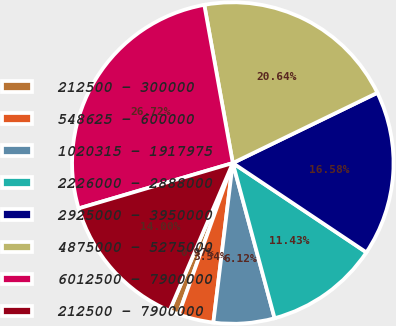<chart> <loc_0><loc_0><loc_500><loc_500><pie_chart><fcel>212500 - 300000<fcel>548625 - 600000<fcel>1020315 - 1917975<fcel>2226000 - 2888000<fcel>2925000 - 3950000<fcel>4875000 - 5275000<fcel>6012500 - 7900000<fcel>212500 - 7900000<nl><fcel>0.97%<fcel>3.54%<fcel>6.12%<fcel>11.43%<fcel>16.58%<fcel>20.64%<fcel>26.72%<fcel>14.0%<nl></chart> 